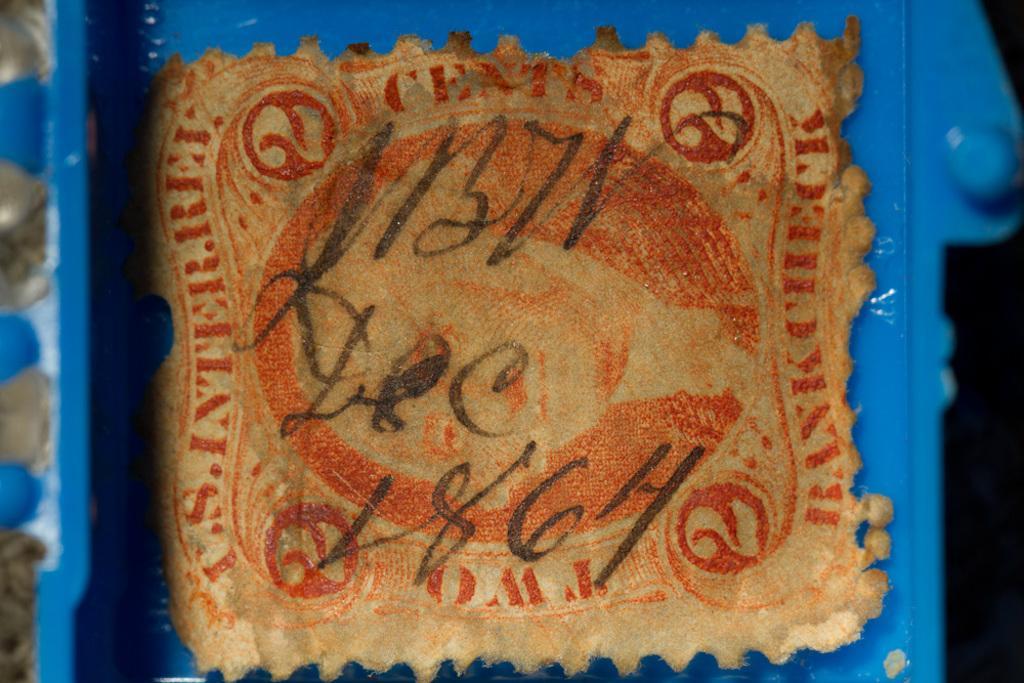Could you give a brief overview of what you see in this image? This is a zoomed in picture. In the foreground there is a blue color object and we can see a cloth on which we can see the text is written. 